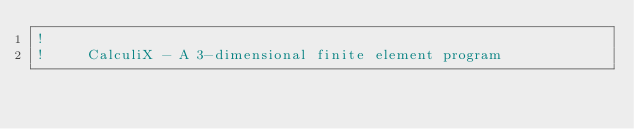<code> <loc_0><loc_0><loc_500><loc_500><_FORTRAN_>!
!     CalculiX - A 3-dimensional finite element program</code> 